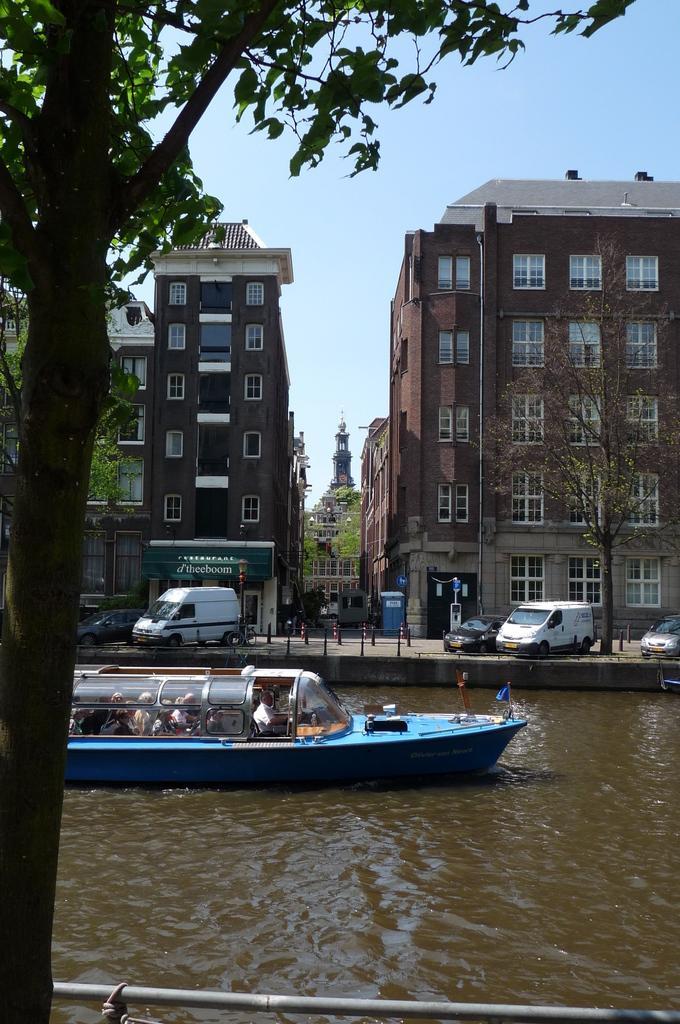Please provide a concise description of this image. In this image I can see buildings in the middle , in front of buildings I can see vehicles and trees ,at the bottom I can see the lake and on the lake I can see a boat,at the top I can see the sky. 